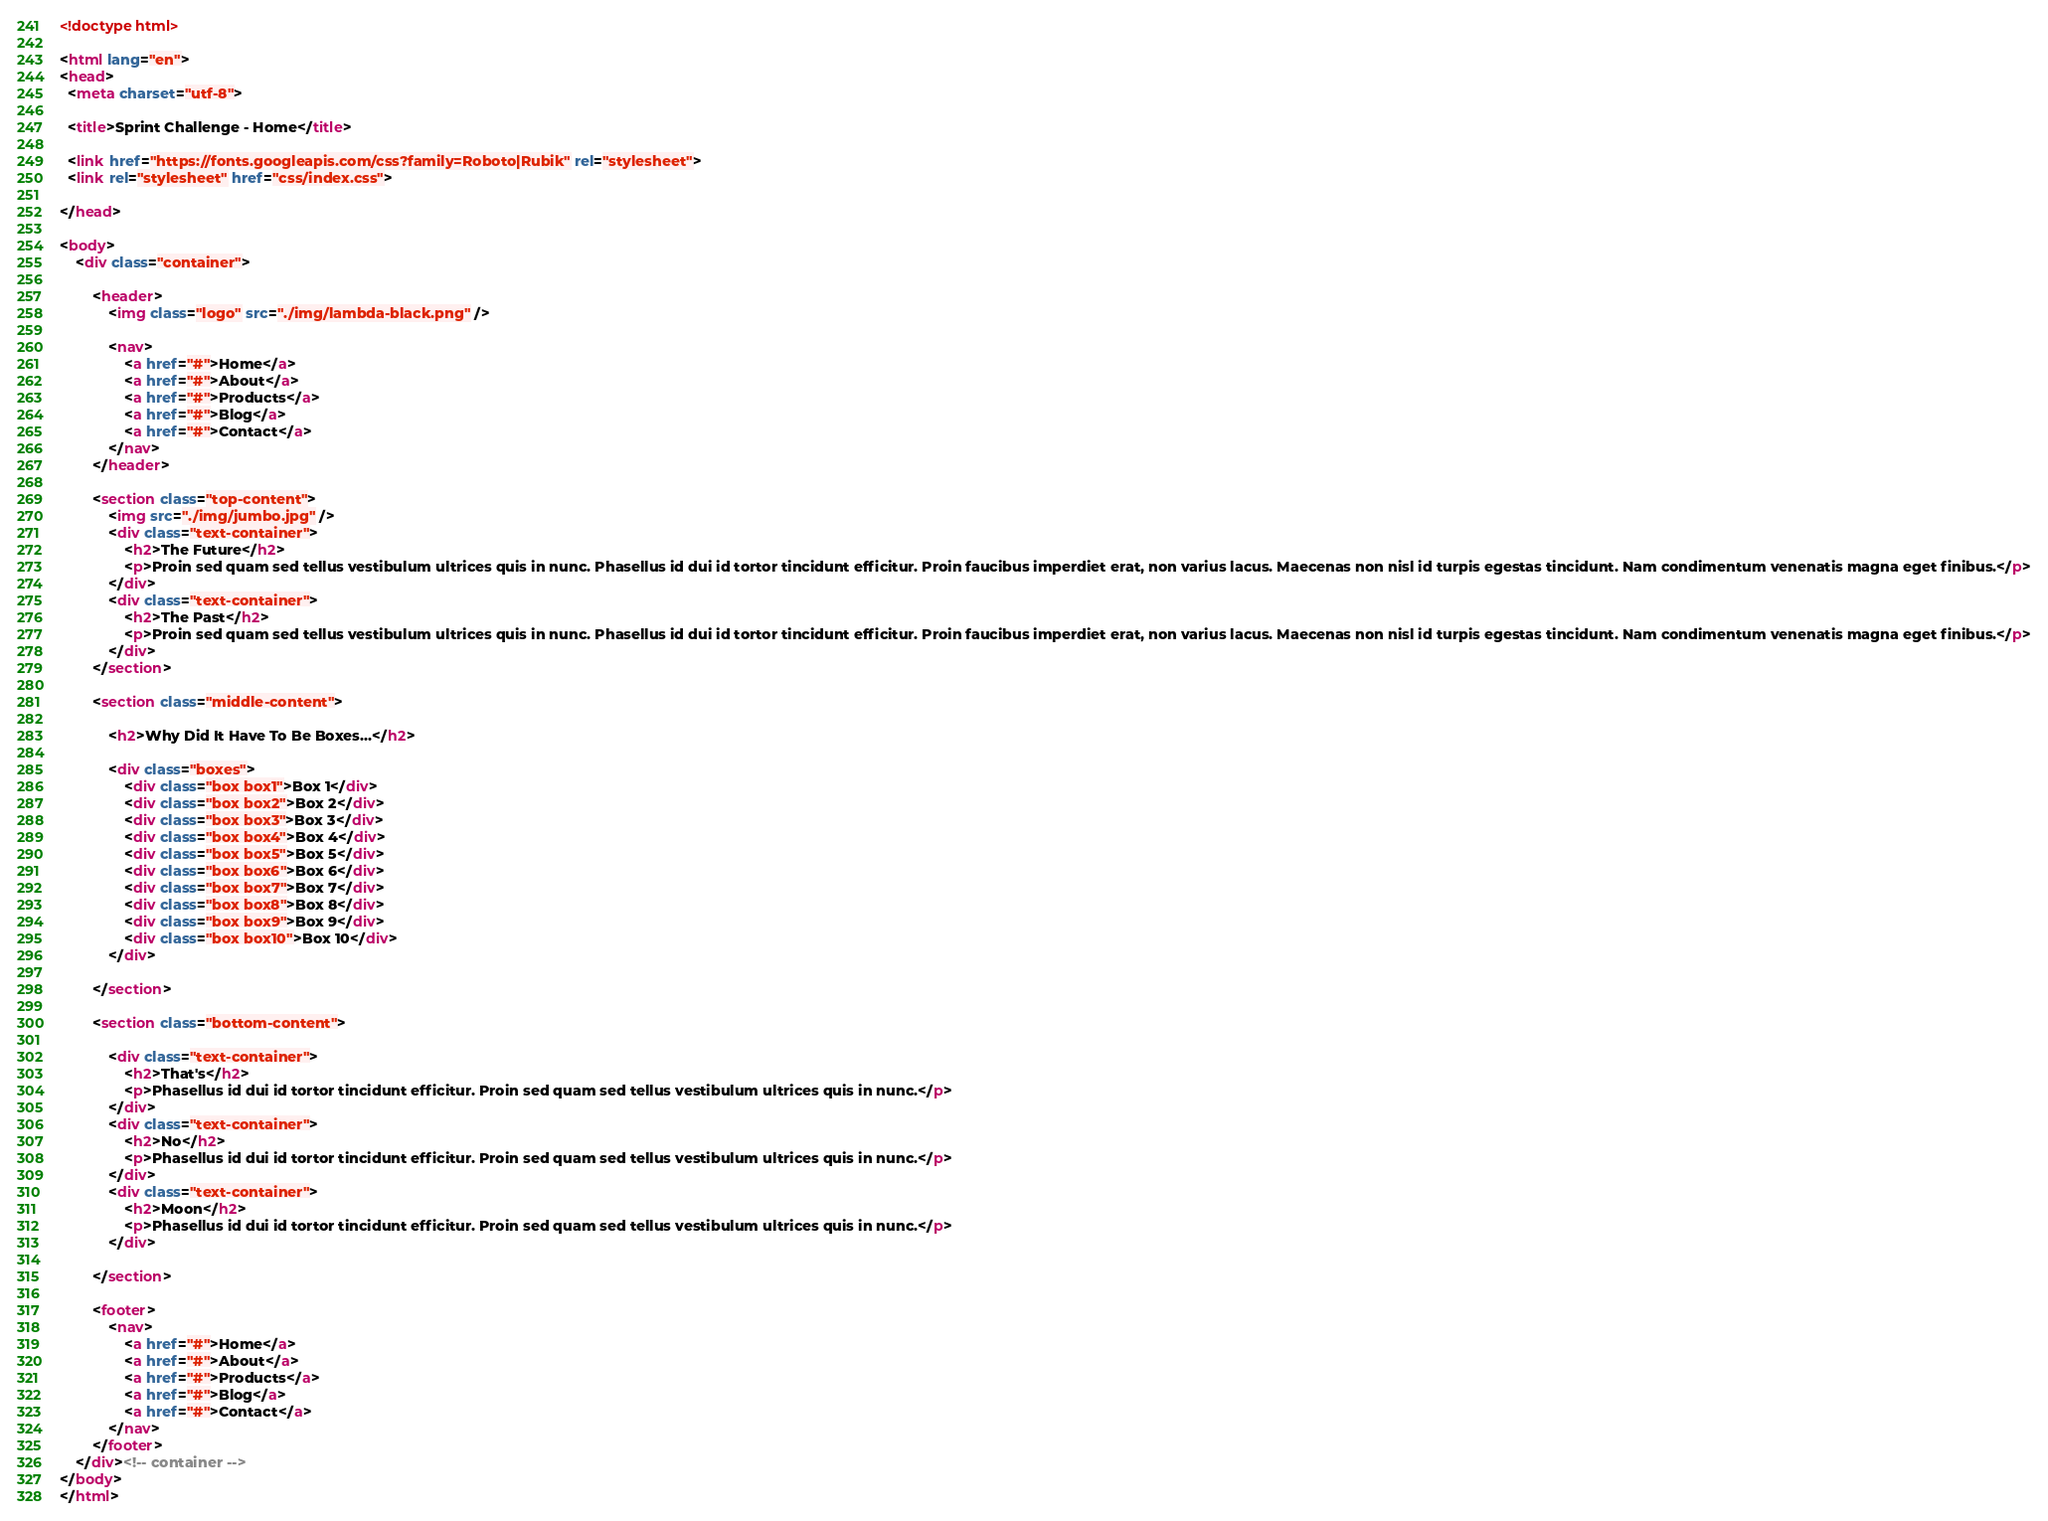Convert code to text. <code><loc_0><loc_0><loc_500><loc_500><_HTML_><!doctype html>

<html lang="en">
<head>
  <meta charset="utf-8">

  <title>Sprint Challenge - Home</title>

  <link href="https://fonts.googleapis.com/css?family=Roboto|Rubik" rel="stylesheet">
  <link rel="stylesheet" href="css/index.css">

</head>

<body>
    <div class="container">
   
        <header>
            <img class="logo" src="./img/lambda-black.png" />

            <nav>
                <a href="#">Home</a>
                <a href="#">About</a>
                <a href="#">Products</a>
                <a href="#">Blog</a>
                <a href="#">Contact</a>
            </nav>
        </header>

        <section class="top-content">
            <img src="./img/jumbo.jpg" />
            <div class="text-container">
                <h2>The Future</h2>
                <p>Proin sed quam sed tellus vestibulum ultrices quis in nunc. Phasellus id dui id tortor tincidunt efficitur. Proin faucibus imperdiet erat, non varius lacus. Maecenas non nisl id turpis egestas tincidunt. Nam condimentum venenatis magna eget finibus.</p>
            </div>
            <div class="text-container">
                <h2>The Past</h2>
                <p>Proin sed quam sed tellus vestibulum ultrices quis in nunc. Phasellus id dui id tortor tincidunt efficitur. Proin faucibus imperdiet erat, non varius lacus. Maecenas non nisl id turpis egestas tincidunt. Nam condimentum venenatis magna eget finibus.</p>
            </div>
        </section>
        
        <section class="middle-content">
        
            <h2>Why Did It Have To Be Boxes...</h2>
            
            <div class="boxes">
                <div class="box box1">Box 1</div>
                <div class="box box2">Box 2</div>
                <div class="box box3">Box 3</div>
                <div class="box box4">Box 4</div>
                <div class="box box5">Box 5</div>
                <div class="box box6">Box 6</div>
                <div class="box box7">Box 7</div>
                <div class="box box8">Box 8</div>
                <div class="box box9">Box 9</div>
                <div class="box box10">Box 10</div>
            </div>
        
        </section>

        <section class="bottom-content">

            <div class="text-container">
                <h2>That's</h2>
                <p>Phasellus id dui id tortor tincidunt efficitur. Proin sed quam sed tellus vestibulum ultrices quis in nunc.</p>
            </div>
            <div class="text-container">
                <h2>No</h2>
                <p>Phasellus id dui id tortor tincidunt efficitur. Proin sed quam sed tellus vestibulum ultrices quis in nunc.</p>
            </div>
            <div class="text-container">
                <h2>Moon</h2>
                <p>Phasellus id dui id tortor tincidunt efficitur. Proin sed quam sed tellus vestibulum ultrices quis in nunc.</p>
            </div>

        </section>
        
        <footer>
            <nav>
                <a href="#">Home</a>
                <a href="#">About</a>
                <a href="#">Products</a>
                <a href="#">Blog</a>
                <a href="#">Contact</a>
            </nav>
        </footer>
    </div><!-- container -->        
</body>
</html></code> 